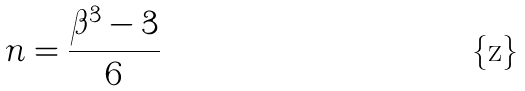<formula> <loc_0><loc_0><loc_500><loc_500>n = \frac { \beta ^ { 3 } - 3 } { 6 }</formula> 